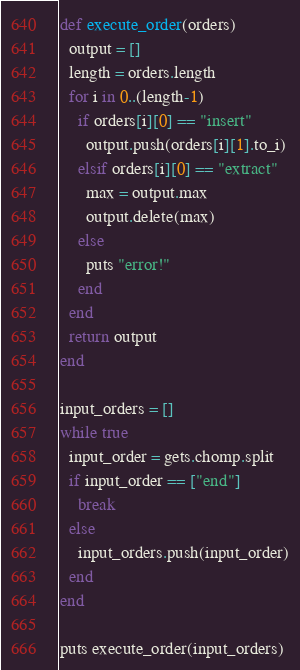Convert code to text. <code><loc_0><loc_0><loc_500><loc_500><_Ruby_>

def execute_order(orders)
  output = []
  length = orders.length
  for i in 0..(length-1)
    if orders[i][0] == "insert"
      output.push(orders[i][1].to_i)
    elsif orders[i][0] == "extract"
      max = output.max
      output.delete(max)
    else
      puts "error!"
    end
  end
  return output
end

input_orders = []
while true
  input_order = gets.chomp.split
  if input_order == ["end"]
    break
  else
    input_orders.push(input_order)
  end
end

puts execute_order(input_orders)</code> 